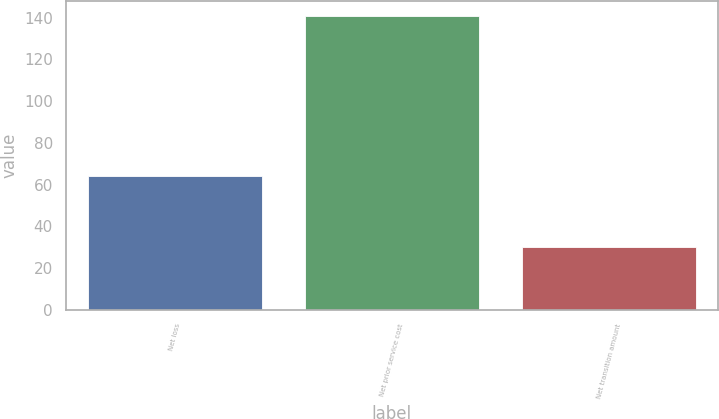Convert chart to OTSL. <chart><loc_0><loc_0><loc_500><loc_500><bar_chart><fcel>Net loss<fcel>Net prior service cost<fcel>Net transition amount<nl><fcel>64<fcel>141<fcel>30<nl></chart> 